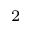<formula> <loc_0><loc_0><loc_500><loc_500>^ { 2 }</formula> 